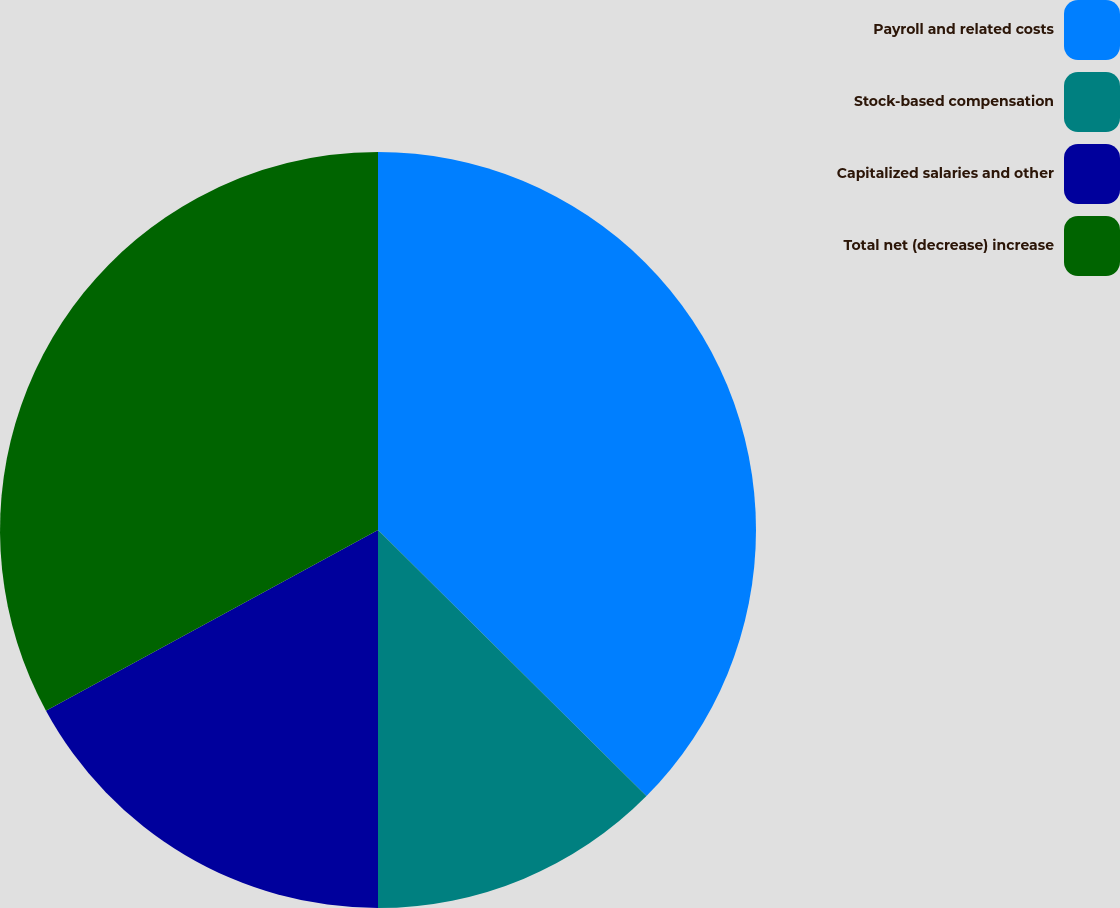Convert chart to OTSL. <chart><loc_0><loc_0><loc_500><loc_500><pie_chart><fcel>Payroll and related costs<fcel>Stock-based compensation<fcel>Capitalized salaries and other<fcel>Total net (decrease) increase<nl><fcel>37.43%<fcel>12.57%<fcel>17.07%<fcel>32.93%<nl></chart> 